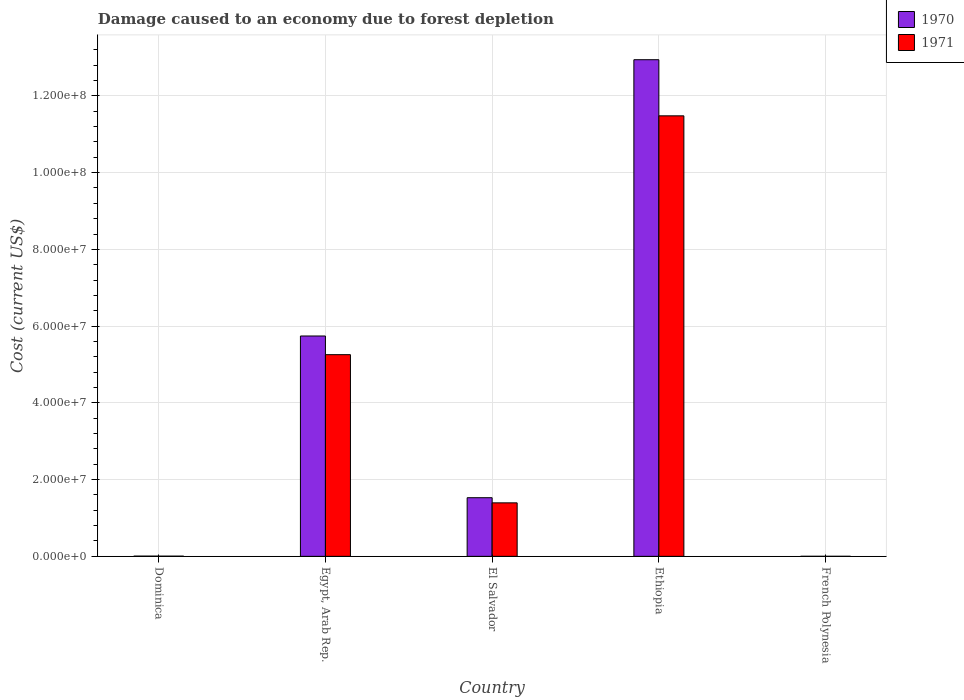How many different coloured bars are there?
Your response must be concise. 2. Are the number of bars per tick equal to the number of legend labels?
Give a very brief answer. Yes. How many bars are there on the 4th tick from the right?
Give a very brief answer. 2. What is the label of the 5th group of bars from the left?
Offer a terse response. French Polynesia. What is the cost of damage caused due to forest depletion in 1971 in French Polynesia?
Give a very brief answer. 9061.15. Across all countries, what is the maximum cost of damage caused due to forest depletion in 1971?
Your answer should be compact. 1.15e+08. Across all countries, what is the minimum cost of damage caused due to forest depletion in 1970?
Your response must be concise. 1.18e+04. In which country was the cost of damage caused due to forest depletion in 1971 maximum?
Your response must be concise. Ethiopia. In which country was the cost of damage caused due to forest depletion in 1970 minimum?
Offer a very short reply. French Polynesia. What is the total cost of damage caused due to forest depletion in 1971 in the graph?
Give a very brief answer. 1.81e+08. What is the difference between the cost of damage caused due to forest depletion in 1970 in Egypt, Arab Rep. and that in French Polynesia?
Ensure brevity in your answer.  5.74e+07. What is the difference between the cost of damage caused due to forest depletion in 1971 in French Polynesia and the cost of damage caused due to forest depletion in 1970 in Dominica?
Give a very brief answer. -5.08e+04. What is the average cost of damage caused due to forest depletion in 1971 per country?
Offer a terse response. 3.63e+07. What is the difference between the cost of damage caused due to forest depletion of/in 1971 and cost of damage caused due to forest depletion of/in 1970 in El Salvador?
Give a very brief answer. -1.34e+06. In how many countries, is the cost of damage caused due to forest depletion in 1971 greater than 4000000 US$?
Offer a terse response. 3. What is the ratio of the cost of damage caused due to forest depletion in 1970 in El Salvador to that in French Polynesia?
Keep it short and to the point. 1300.42. Is the cost of damage caused due to forest depletion in 1970 in Egypt, Arab Rep. less than that in French Polynesia?
Offer a terse response. No. What is the difference between the highest and the second highest cost of damage caused due to forest depletion in 1971?
Provide a short and direct response. 6.22e+07. What is the difference between the highest and the lowest cost of damage caused due to forest depletion in 1970?
Your answer should be compact. 1.29e+08. In how many countries, is the cost of damage caused due to forest depletion in 1971 greater than the average cost of damage caused due to forest depletion in 1971 taken over all countries?
Keep it short and to the point. 2. What does the 1st bar from the left in Ethiopia represents?
Make the answer very short. 1970. Are all the bars in the graph horizontal?
Offer a terse response. No. What is the difference between two consecutive major ticks on the Y-axis?
Offer a terse response. 2.00e+07. Does the graph contain grids?
Your answer should be very brief. Yes. How are the legend labels stacked?
Keep it short and to the point. Vertical. What is the title of the graph?
Offer a very short reply. Damage caused to an economy due to forest depletion. What is the label or title of the Y-axis?
Make the answer very short. Cost (current US$). What is the Cost (current US$) in 1970 in Dominica?
Your answer should be compact. 5.98e+04. What is the Cost (current US$) in 1971 in Dominica?
Ensure brevity in your answer.  5.09e+04. What is the Cost (current US$) of 1970 in Egypt, Arab Rep.?
Keep it short and to the point. 5.74e+07. What is the Cost (current US$) in 1971 in Egypt, Arab Rep.?
Keep it short and to the point. 5.26e+07. What is the Cost (current US$) in 1970 in El Salvador?
Your response must be concise. 1.53e+07. What is the Cost (current US$) of 1971 in El Salvador?
Your answer should be very brief. 1.39e+07. What is the Cost (current US$) in 1970 in Ethiopia?
Offer a very short reply. 1.29e+08. What is the Cost (current US$) of 1971 in Ethiopia?
Your answer should be very brief. 1.15e+08. What is the Cost (current US$) in 1970 in French Polynesia?
Provide a succinct answer. 1.18e+04. What is the Cost (current US$) in 1971 in French Polynesia?
Your response must be concise. 9061.15. Across all countries, what is the maximum Cost (current US$) of 1970?
Give a very brief answer. 1.29e+08. Across all countries, what is the maximum Cost (current US$) of 1971?
Ensure brevity in your answer.  1.15e+08. Across all countries, what is the minimum Cost (current US$) of 1970?
Your answer should be very brief. 1.18e+04. Across all countries, what is the minimum Cost (current US$) in 1971?
Make the answer very short. 9061.15. What is the total Cost (current US$) of 1970 in the graph?
Offer a very short reply. 2.02e+08. What is the total Cost (current US$) of 1971 in the graph?
Your answer should be very brief. 1.81e+08. What is the difference between the Cost (current US$) in 1970 in Dominica and that in Egypt, Arab Rep.?
Provide a short and direct response. -5.74e+07. What is the difference between the Cost (current US$) in 1971 in Dominica and that in Egypt, Arab Rep.?
Offer a terse response. -5.25e+07. What is the difference between the Cost (current US$) of 1970 in Dominica and that in El Salvador?
Make the answer very short. -1.52e+07. What is the difference between the Cost (current US$) in 1971 in Dominica and that in El Salvador?
Your response must be concise. -1.39e+07. What is the difference between the Cost (current US$) of 1970 in Dominica and that in Ethiopia?
Provide a short and direct response. -1.29e+08. What is the difference between the Cost (current US$) in 1971 in Dominica and that in Ethiopia?
Your response must be concise. -1.15e+08. What is the difference between the Cost (current US$) in 1970 in Dominica and that in French Polynesia?
Offer a very short reply. 4.81e+04. What is the difference between the Cost (current US$) in 1971 in Dominica and that in French Polynesia?
Provide a short and direct response. 4.18e+04. What is the difference between the Cost (current US$) of 1970 in Egypt, Arab Rep. and that in El Salvador?
Make the answer very short. 4.21e+07. What is the difference between the Cost (current US$) of 1971 in Egypt, Arab Rep. and that in El Salvador?
Your answer should be compact. 3.86e+07. What is the difference between the Cost (current US$) in 1970 in Egypt, Arab Rep. and that in Ethiopia?
Provide a succinct answer. -7.20e+07. What is the difference between the Cost (current US$) in 1971 in Egypt, Arab Rep. and that in Ethiopia?
Provide a succinct answer. -6.22e+07. What is the difference between the Cost (current US$) of 1970 in Egypt, Arab Rep. and that in French Polynesia?
Provide a short and direct response. 5.74e+07. What is the difference between the Cost (current US$) in 1971 in Egypt, Arab Rep. and that in French Polynesia?
Your answer should be very brief. 5.26e+07. What is the difference between the Cost (current US$) of 1970 in El Salvador and that in Ethiopia?
Offer a terse response. -1.14e+08. What is the difference between the Cost (current US$) in 1971 in El Salvador and that in Ethiopia?
Give a very brief answer. -1.01e+08. What is the difference between the Cost (current US$) in 1970 in El Salvador and that in French Polynesia?
Your answer should be very brief. 1.53e+07. What is the difference between the Cost (current US$) in 1971 in El Salvador and that in French Polynesia?
Your answer should be very brief. 1.39e+07. What is the difference between the Cost (current US$) in 1970 in Ethiopia and that in French Polynesia?
Keep it short and to the point. 1.29e+08. What is the difference between the Cost (current US$) of 1971 in Ethiopia and that in French Polynesia?
Offer a terse response. 1.15e+08. What is the difference between the Cost (current US$) in 1970 in Dominica and the Cost (current US$) in 1971 in Egypt, Arab Rep.?
Give a very brief answer. -5.25e+07. What is the difference between the Cost (current US$) in 1970 in Dominica and the Cost (current US$) in 1971 in El Salvador?
Ensure brevity in your answer.  -1.39e+07. What is the difference between the Cost (current US$) of 1970 in Dominica and the Cost (current US$) of 1971 in Ethiopia?
Keep it short and to the point. -1.15e+08. What is the difference between the Cost (current US$) of 1970 in Dominica and the Cost (current US$) of 1971 in French Polynesia?
Offer a terse response. 5.08e+04. What is the difference between the Cost (current US$) of 1970 in Egypt, Arab Rep. and the Cost (current US$) of 1971 in El Salvador?
Provide a short and direct response. 4.35e+07. What is the difference between the Cost (current US$) of 1970 in Egypt, Arab Rep. and the Cost (current US$) of 1971 in Ethiopia?
Provide a succinct answer. -5.74e+07. What is the difference between the Cost (current US$) of 1970 in Egypt, Arab Rep. and the Cost (current US$) of 1971 in French Polynesia?
Make the answer very short. 5.74e+07. What is the difference between the Cost (current US$) of 1970 in El Salvador and the Cost (current US$) of 1971 in Ethiopia?
Provide a succinct answer. -9.95e+07. What is the difference between the Cost (current US$) of 1970 in El Salvador and the Cost (current US$) of 1971 in French Polynesia?
Give a very brief answer. 1.53e+07. What is the difference between the Cost (current US$) of 1970 in Ethiopia and the Cost (current US$) of 1971 in French Polynesia?
Your answer should be compact. 1.29e+08. What is the average Cost (current US$) of 1970 per country?
Offer a very short reply. 4.04e+07. What is the average Cost (current US$) in 1971 per country?
Your answer should be compact. 3.63e+07. What is the difference between the Cost (current US$) of 1970 and Cost (current US$) of 1971 in Dominica?
Your response must be concise. 8949.07. What is the difference between the Cost (current US$) of 1970 and Cost (current US$) of 1971 in Egypt, Arab Rep.?
Keep it short and to the point. 4.87e+06. What is the difference between the Cost (current US$) in 1970 and Cost (current US$) in 1971 in El Salvador?
Offer a very short reply. 1.34e+06. What is the difference between the Cost (current US$) of 1970 and Cost (current US$) of 1971 in Ethiopia?
Offer a terse response. 1.46e+07. What is the difference between the Cost (current US$) of 1970 and Cost (current US$) of 1971 in French Polynesia?
Make the answer very short. 2690.05. What is the ratio of the Cost (current US$) of 1971 in Dominica to that in Egypt, Arab Rep.?
Provide a short and direct response. 0. What is the ratio of the Cost (current US$) of 1970 in Dominica to that in El Salvador?
Provide a short and direct response. 0. What is the ratio of the Cost (current US$) of 1971 in Dominica to that in El Salvador?
Your answer should be compact. 0. What is the ratio of the Cost (current US$) of 1970 in Dominica to that in French Polynesia?
Offer a very short reply. 5.09. What is the ratio of the Cost (current US$) in 1971 in Dominica to that in French Polynesia?
Ensure brevity in your answer.  5.61. What is the ratio of the Cost (current US$) of 1970 in Egypt, Arab Rep. to that in El Salvador?
Provide a succinct answer. 3.76. What is the ratio of the Cost (current US$) in 1971 in Egypt, Arab Rep. to that in El Salvador?
Offer a very short reply. 3.77. What is the ratio of the Cost (current US$) of 1970 in Egypt, Arab Rep. to that in Ethiopia?
Keep it short and to the point. 0.44. What is the ratio of the Cost (current US$) of 1971 in Egypt, Arab Rep. to that in Ethiopia?
Give a very brief answer. 0.46. What is the ratio of the Cost (current US$) of 1970 in Egypt, Arab Rep. to that in French Polynesia?
Offer a very short reply. 4887.16. What is the ratio of the Cost (current US$) in 1971 in Egypt, Arab Rep. to that in French Polynesia?
Provide a succinct answer. 5800.64. What is the ratio of the Cost (current US$) in 1970 in El Salvador to that in Ethiopia?
Make the answer very short. 0.12. What is the ratio of the Cost (current US$) in 1971 in El Salvador to that in Ethiopia?
Keep it short and to the point. 0.12. What is the ratio of the Cost (current US$) of 1970 in El Salvador to that in French Polynesia?
Your answer should be very brief. 1300.42. What is the ratio of the Cost (current US$) of 1971 in El Salvador to that in French Polynesia?
Provide a short and direct response. 1538.5. What is the ratio of the Cost (current US$) in 1970 in Ethiopia to that in French Polynesia?
Your response must be concise. 1.10e+04. What is the ratio of the Cost (current US$) in 1971 in Ethiopia to that in French Polynesia?
Your answer should be very brief. 1.27e+04. What is the difference between the highest and the second highest Cost (current US$) of 1970?
Keep it short and to the point. 7.20e+07. What is the difference between the highest and the second highest Cost (current US$) of 1971?
Your response must be concise. 6.22e+07. What is the difference between the highest and the lowest Cost (current US$) in 1970?
Provide a short and direct response. 1.29e+08. What is the difference between the highest and the lowest Cost (current US$) of 1971?
Make the answer very short. 1.15e+08. 